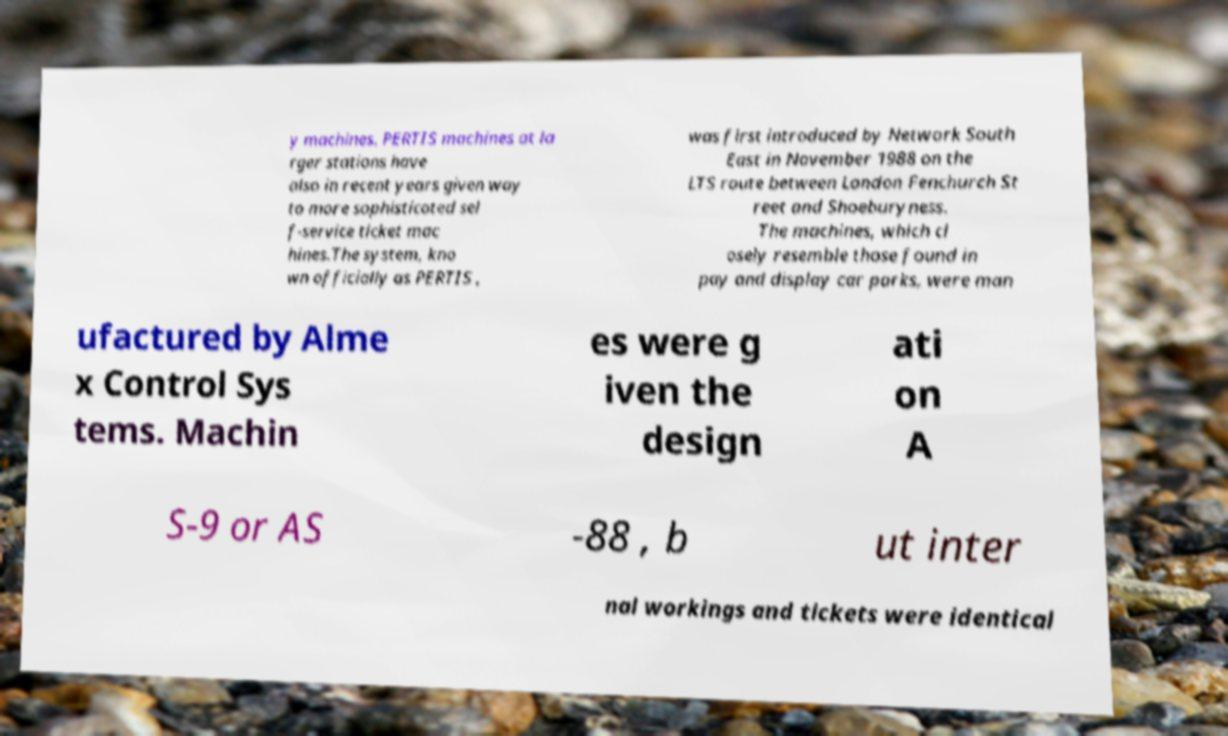Can you accurately transcribe the text from the provided image for me? y machines. PERTIS machines at la rger stations have also in recent years given way to more sophisticated sel f-service ticket mac hines.The system, kno wn officially as PERTIS , was first introduced by Network South East in November 1988 on the LTS route between London Fenchurch St reet and Shoeburyness. The machines, which cl osely resemble those found in pay and display car parks, were man ufactured by Alme x Control Sys tems. Machin es were g iven the design ati on A S-9 or AS -88 , b ut inter nal workings and tickets were identical 